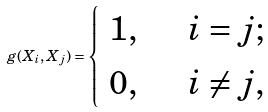Convert formula to latex. <formula><loc_0><loc_0><loc_500><loc_500>g ( X _ { i } , X _ { j } ) = \begin{cases} \begin{array} { r l } 1 , \quad & i = j ; \\ 0 , \quad & i \neq j , \end{array} \end{cases}</formula> 